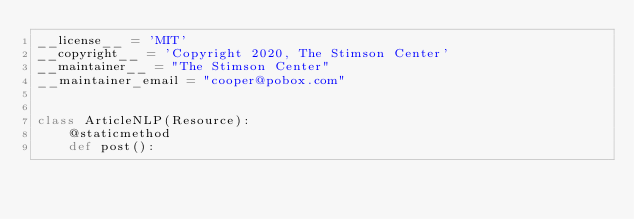Convert code to text. <code><loc_0><loc_0><loc_500><loc_500><_Python_>__license__ = 'MIT'
__copyright__ = 'Copyright 2020, The Stimson Center'
__maintainer__ = "The Stimson Center"
__maintainer_email = "cooper@pobox.com"


class ArticleNLP(Resource):
    @staticmethod
    def post():</code> 